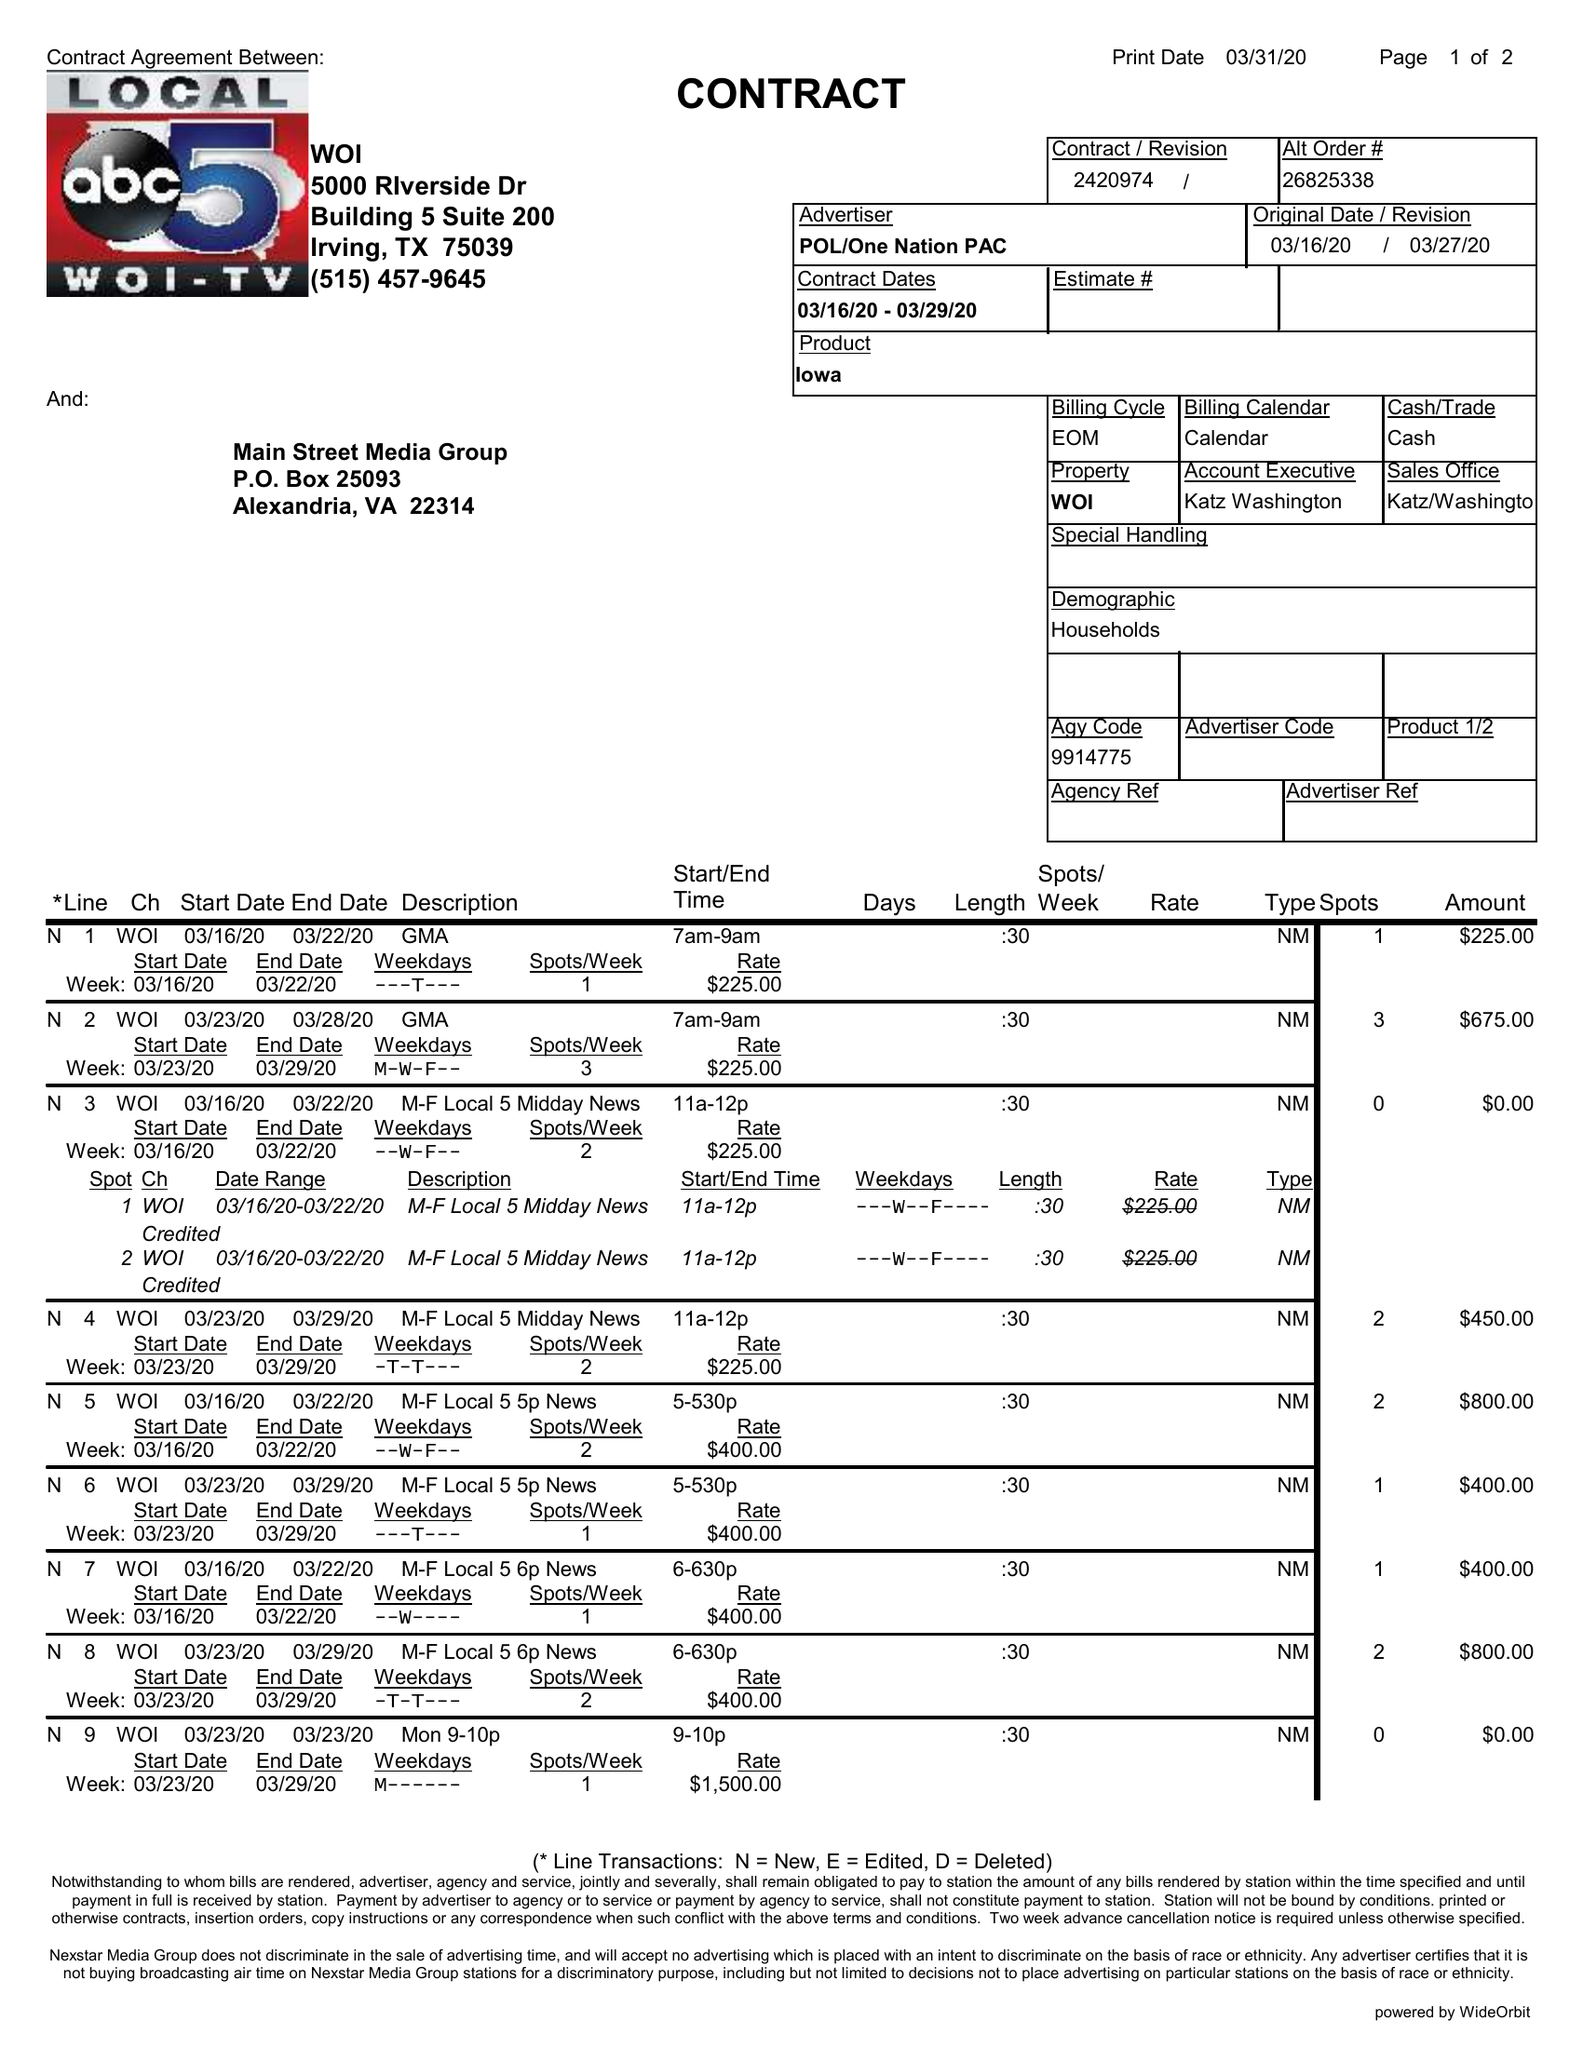What is the value for the flight_to?
Answer the question using a single word or phrase. 03/29/20 